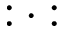<formula> <loc_0><loc_0><loc_500><loc_500>\colon \cdot \colon</formula> 